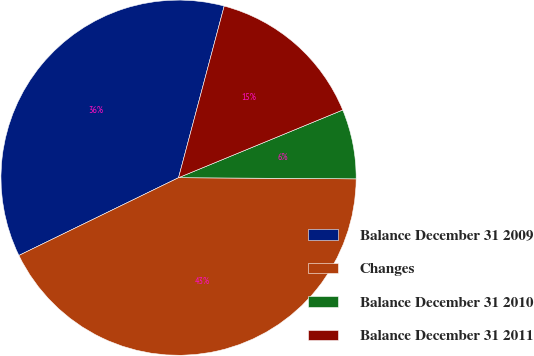Convert chart. <chart><loc_0><loc_0><loc_500><loc_500><pie_chart><fcel>Balance December 31 2009<fcel>Changes<fcel>Balance December 31 2010<fcel>Balance December 31 2011<nl><fcel>36.35%<fcel>42.68%<fcel>6.33%<fcel>14.64%<nl></chart> 